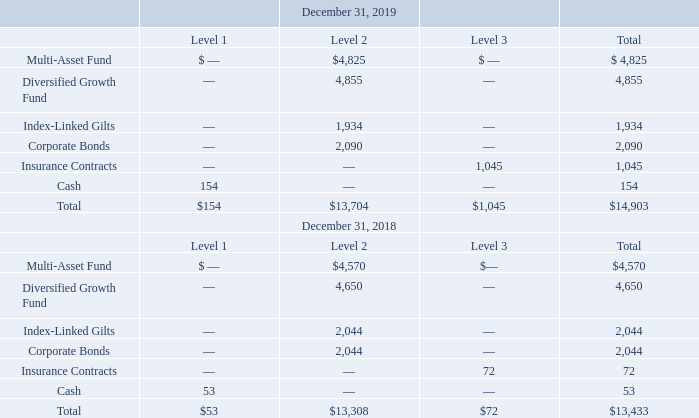ADVANCED ENERGY INDUSTRIES, INC. NOTES TO CONSOLIDATED FINANCIAL STATEMENTS – (continued) (in thousands, except per share amounts)
The fair value of the Company’s qualified pension plan assets by category for the years ended December 31, are as follows:
At December 31, 2019 our plan’s assets of $14.9 million were invested in five separate funds including a multiasset fund (32.4%), a diversified growth fund (32.6%), an index-linked gilt (13.0%), corporate bonds (14.0%), and insurance contracts (7%). The asset and growth funds aim to generate an ‘equity-like’ return over an economic cycle with significantly reduced volatility relative to equity markets and have scope to use a diverse range of asset classes, including equities, bonds, cash and alternatives, e.g. property, infrastructure, high yield bonds, floating rate debt, private, equity, hedge funds and currency. The bond fund and gilt fund are invested in index-linked gilts and corporate bonds. These investments are intended to provide a degree of protection against changes in the value of our plan’s liabilities related to changes in long-term expectations for interest rates and inflation expectations.
What were the funds that the company invested in in 2019? Multi-asset fund, diversified growth fund, index-linked gilt, corporate bonds, insurance contracts. How many assets was in the Level 2 Multi-Asset fund for 2019?
Answer scale should be: thousand. $4,825. How many assets was in the Level 2 Corporate Bonds for 2018?
Answer scale should be: thousand. 2,044. What was the difference in the total assets in the Level 1 Level 2 categories for 2019?
Answer scale should be: thousand. $13,704-$154
Answer: 13550. What was the total of the three highest assets in the Level 2 Category for 2019?
Answer scale should be: thousand. 4,855+$4,825+2,090
Answer: 11770. What percentage of total assets across all categories consisted of assets from the Level One category for 2019?
Answer scale should be: percent. $154/$14,903
Answer: 1.03. 